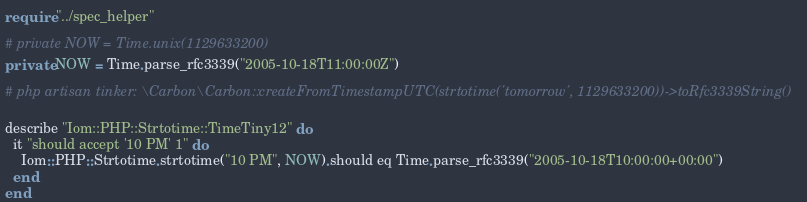<code> <loc_0><loc_0><loc_500><loc_500><_Crystal_>require "../spec_helper"

# private NOW = Time.unix(1129633200)
private NOW = Time.parse_rfc3339("2005-10-18T11:00:00Z")

# php artisan tinker: \Carbon\Carbon::createFromTimestampUTC(strtotime('tomorrow', 1129633200))->toRfc3339String()

describe "Iom::PHP::Strtotime::TimeTiny12" do
  it "should accept '10 PM' 1" do
    Iom::PHP::Strtotime.strtotime("10 PM", NOW).should eq Time.parse_rfc3339("2005-10-18T10:00:00+00:00")
  end
end
</code> 